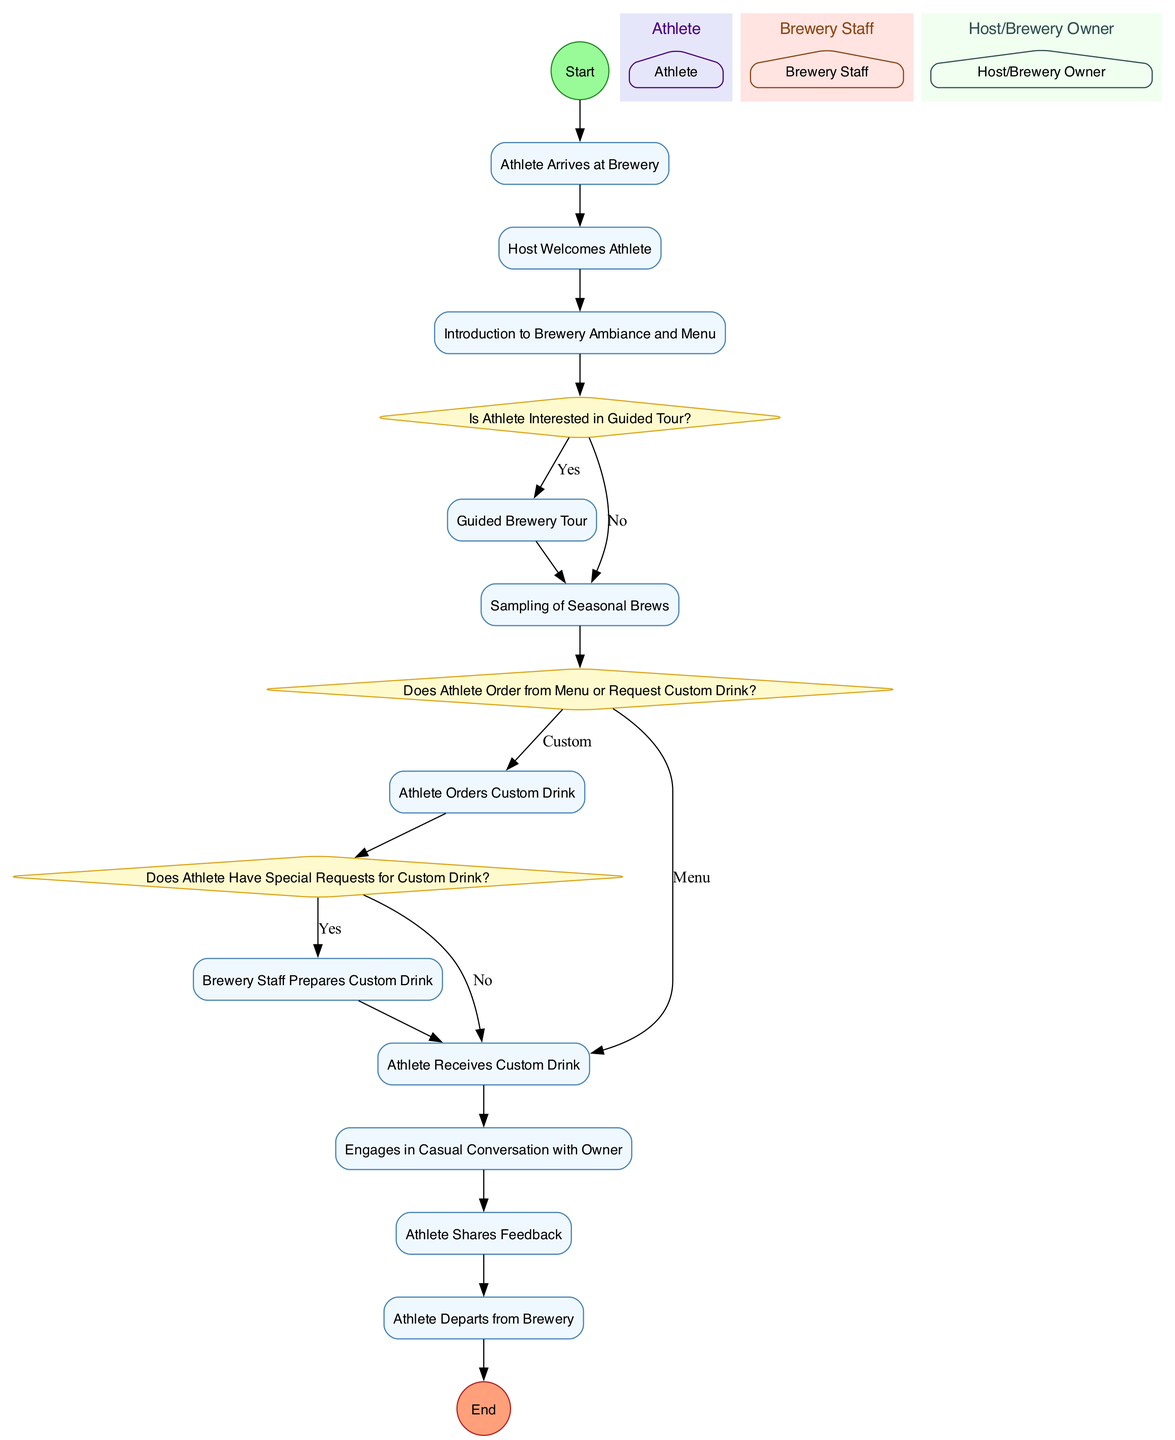What is the first activity in the diagram? The diagram starts with the node labeled "Athlete Arrives at Brewery." This is the initial point of the flow, indicating where the process begins.
Answer: Athlete Arrives at Brewery How many actors are represented in the diagram? There are three actors in the diagram: Athlete, Brewery Staff, and Host/Brewery Owner. Each actor is represented in separate swimlanes in the visual layout.
Answer: 3 Which decision checks if the athlete is interested in the guided tour? The decision labeled "Is Athlete Interested in Guided Tour?" directly follows the activity "Introduction to Brewery Ambiance and Menu." It determines the next steps based on the athlete's interest in participating in a tour.
Answer: Is Athlete Interested in Guided Tour? What is the last activity before the athlete departs from the brewery? The last activity that occurs before the athlete departs is "Athlete Shares Feedback," which precedes the final departure activity in the flow of the diagram.
Answer: Athlete Shares Feedback If the athlete orders a custom drink, what is the next activity? Following the decision to order a custom drink, if that choice is made, the next activity is "Athlete Receives Custom Drink," indicating the fulfillment of their order.
Answer: Athlete Receives Custom Drink What decision occurs after the sampling of seasonal brews? The decision labeled "Does Athlete Order from Menu or Request Custom Drink?" comes immediately after the sampling activity and dictates the subsequent actions based on the athlete's choice.
Answer: Does Athlete Order from Menu or Request Custom Drink? How many edges lead from the decision "Does Athlete Have Special Requests for Custom Drink?" There are two edges leading from this decision: one for "Yes," which goes to "Brewery Staff Prepares Custom Drink," and another for "No," leading directly to "Athlete Receives Custom Drink."
Answer: 2 Which actor engages in casual conversation with the athlete? The actor representing the Host/Brewery Owner engages in casual conversation with the athlete, as shown in the relevant activity node within the owner's swimlane.
Answer: Host/Brewery Owner How does the athlete receive the custom drink if there are special requests? If the athlete has special requests, the flow leads from the decision to "Brewery Staff Prepares Custom Drink," followed by "Athlete Receives Custom Drink," ensuring their specifications are met.
Answer: Brewery Staff Prepares Custom Drink 